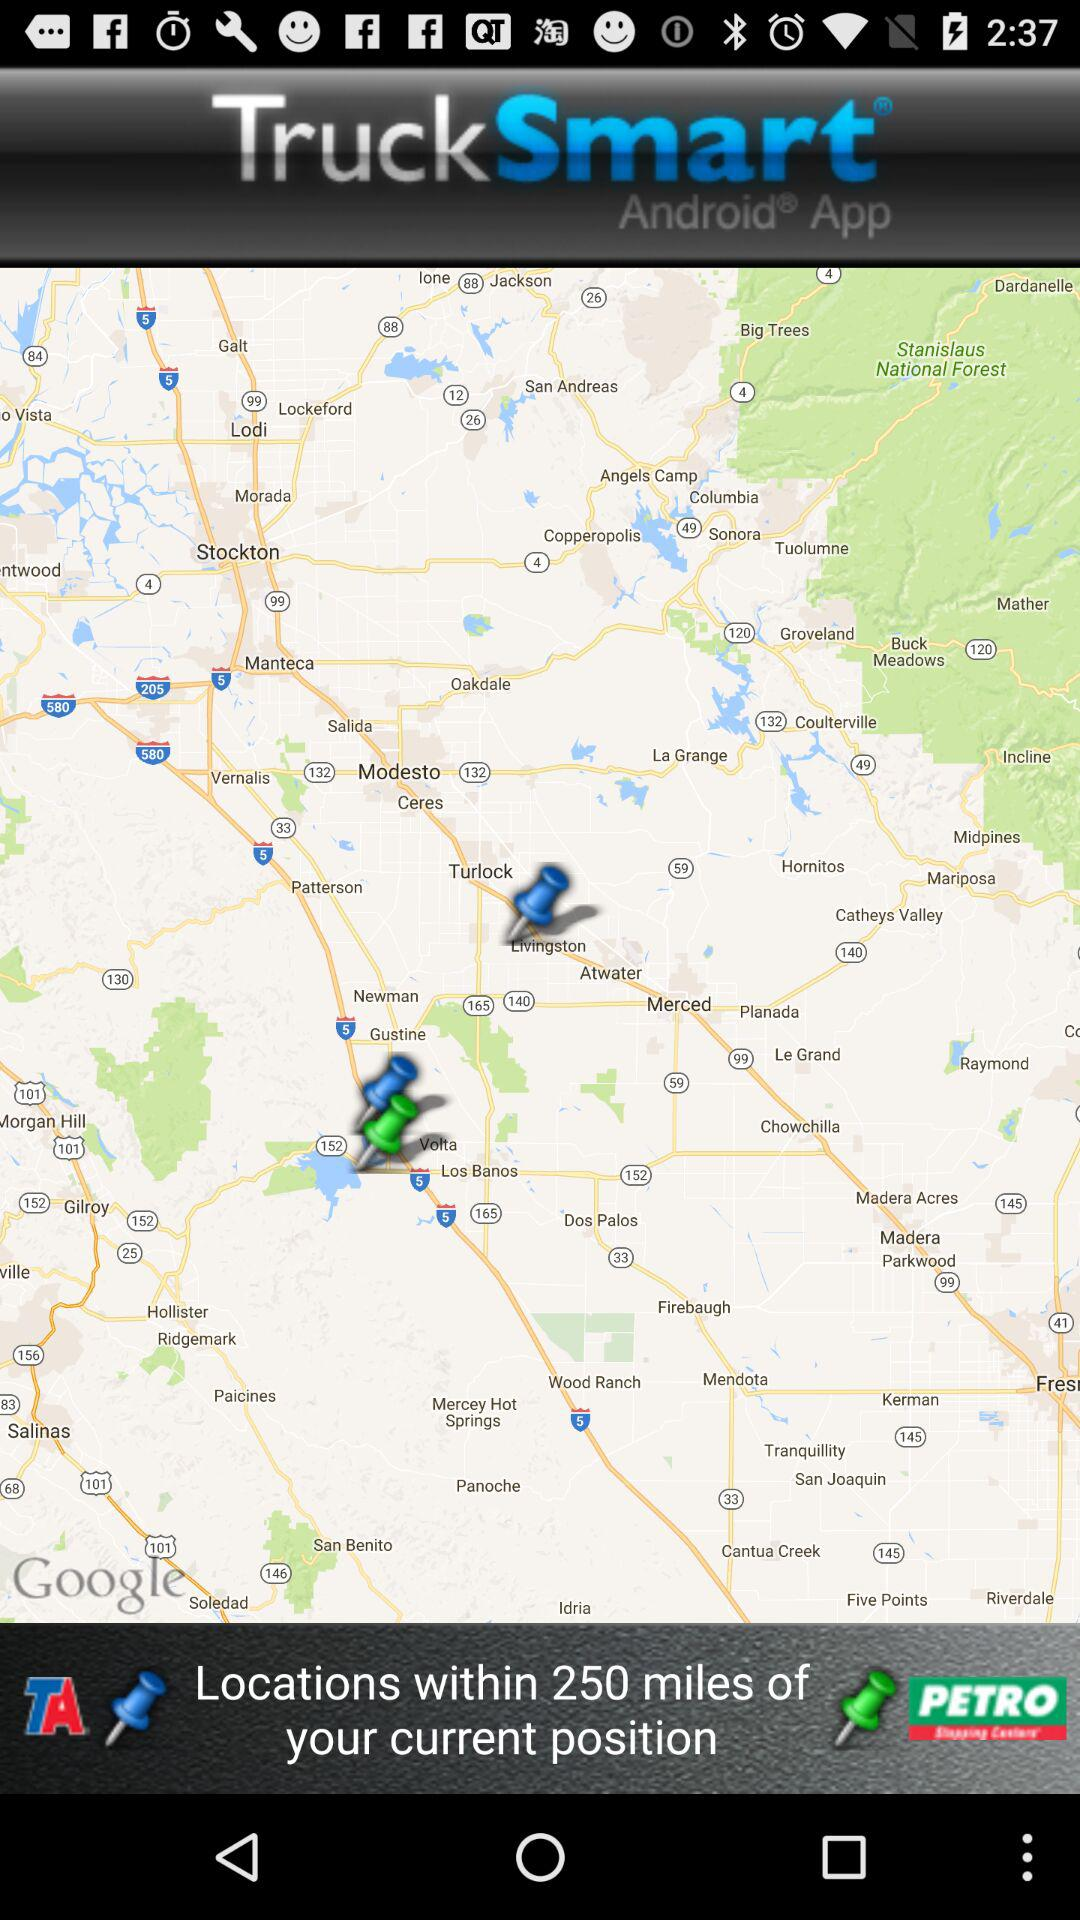What is the distance range shown from my current position? The distance range shown from my current position is within 250 miles. 